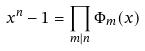Convert formula to latex. <formula><loc_0><loc_0><loc_500><loc_500>x ^ { n } - 1 = \prod _ { m | n } \Phi _ { m } ( x )</formula> 